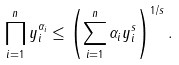<formula> <loc_0><loc_0><loc_500><loc_500>\prod _ { i = 1 } ^ { n } y _ { i } ^ { \alpha _ { i } } \leq \left ( \sum _ { i = 1 } ^ { n } \alpha _ { i } y _ { i } ^ { s } \right ) ^ { 1 / s } .</formula> 